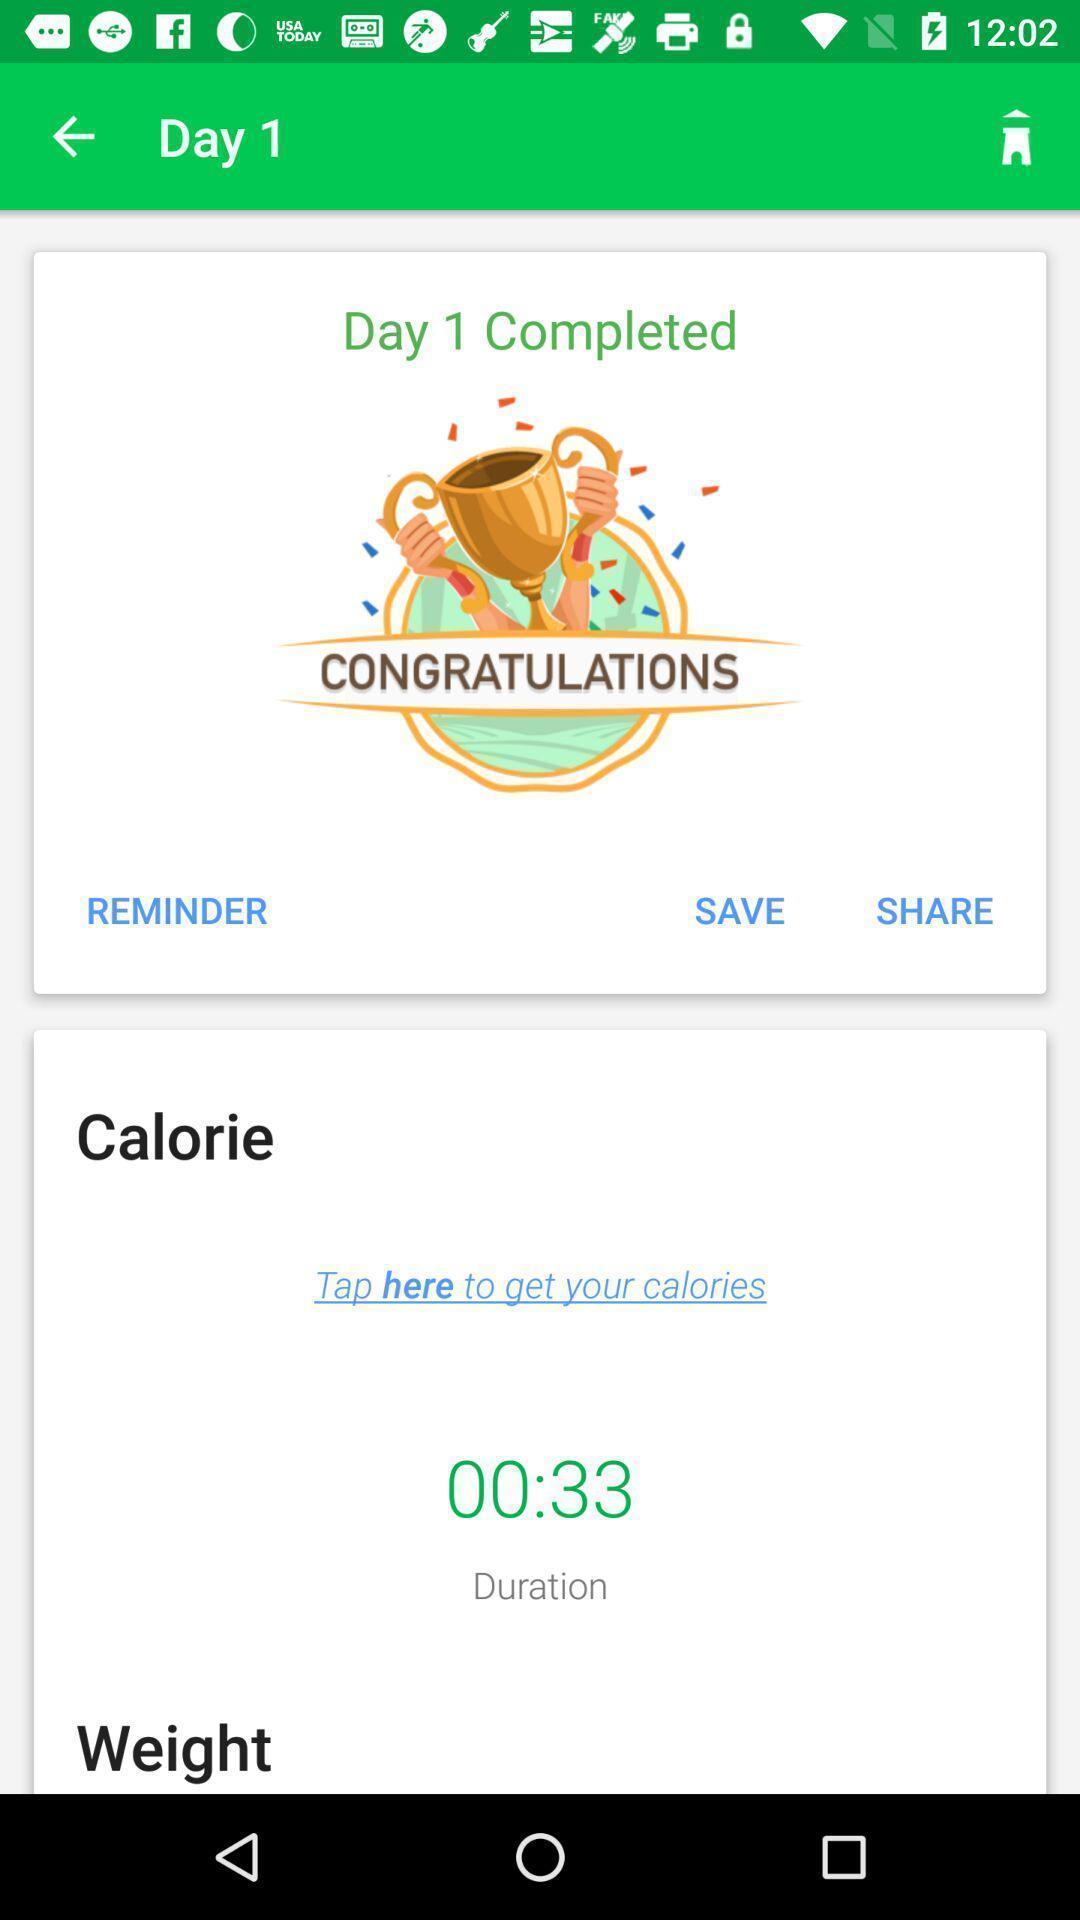Describe the visual elements of this screenshot. Page showing the activities for day one. 